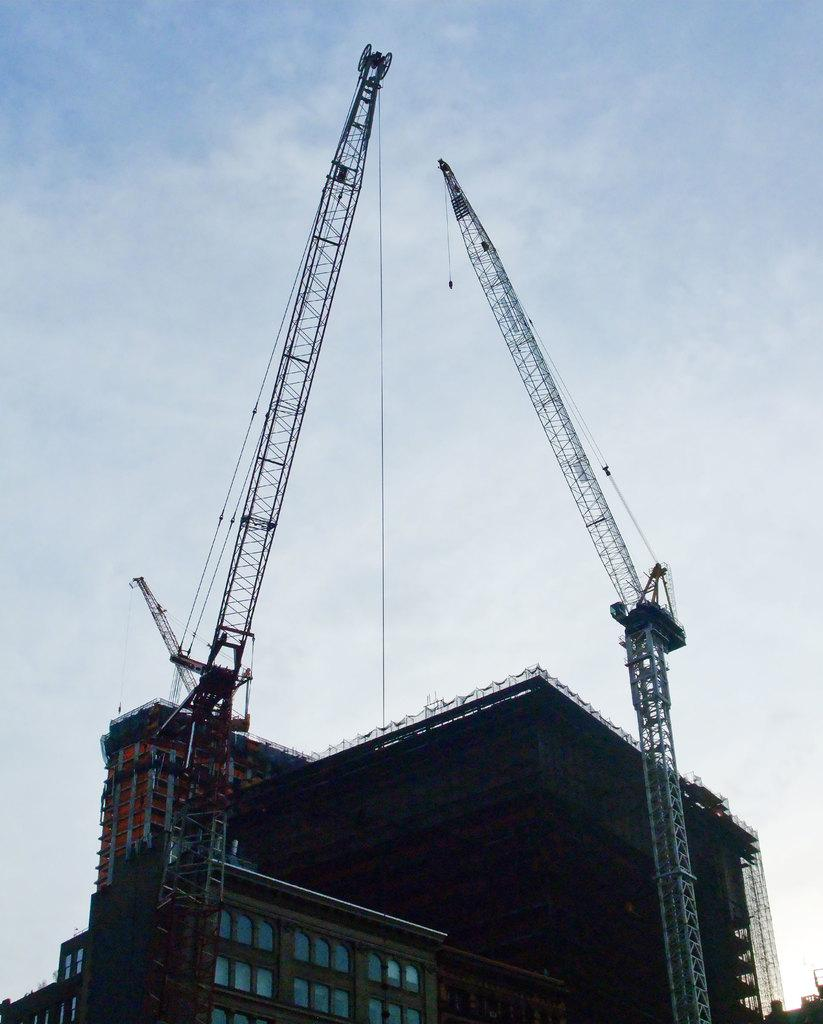What type of structure is present in the image? There is a building in the image. What feature can be observed on the building? The building has glass windows. What construction equipment is visible in the image? There are two cranes in the image. How would you describe the color of the sky in the image? The sky is a combination of white and blue colors. How does the building react to the rainstorm in the image? There is no rainstorm present in the image, so the building's reaction cannot be determined. Can you tell me how many times the building sneezes in the image? Buildings do not sneeze, so this question cannot be answered. 